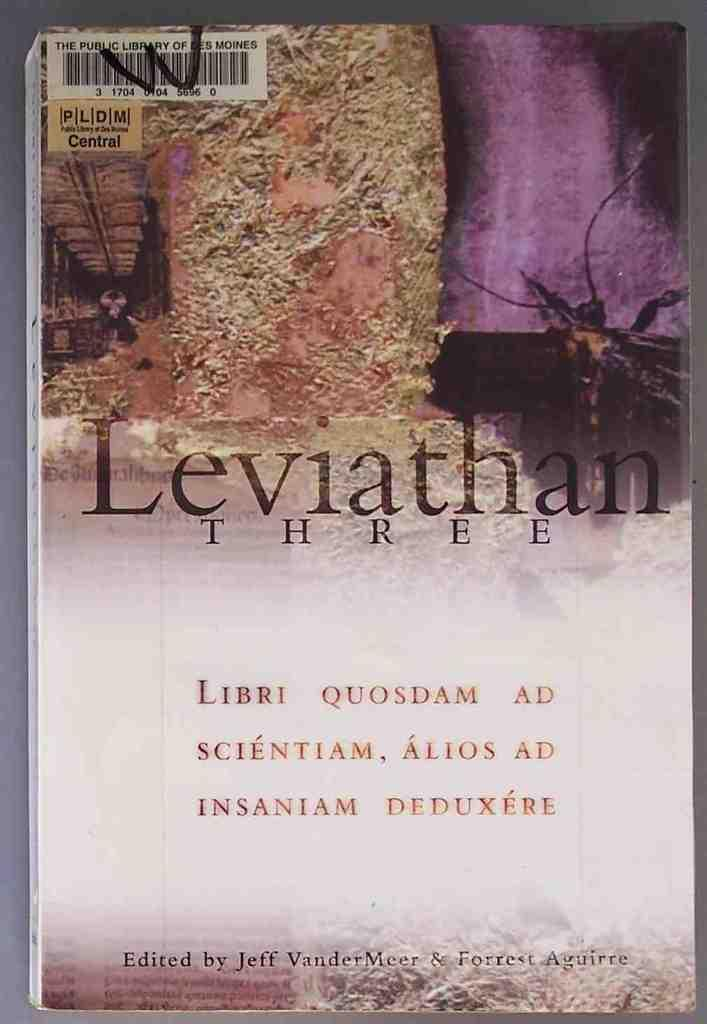Provide a one-sentence caption for the provided image. A book by the title of Leviathan three. 